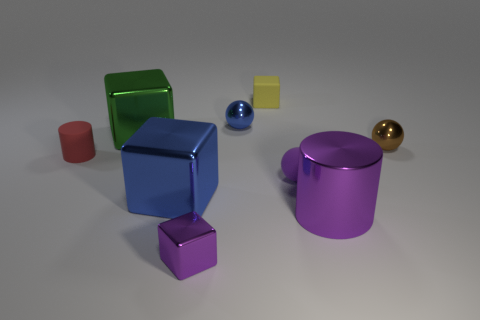Subtract all cylinders. How many objects are left? 7 Add 3 balls. How many balls are left? 6 Add 4 small brown cylinders. How many small brown cylinders exist? 4 Subtract 1 purple spheres. How many objects are left? 8 Subtract all large cyan balls. Subtract all tiny brown objects. How many objects are left? 8 